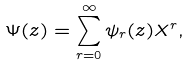Convert formula to latex. <formula><loc_0><loc_0><loc_500><loc_500>\Psi ( z ) = \sum ^ { \infty } _ { r = 0 } \psi _ { r } ( z ) X ^ { r } ,</formula> 